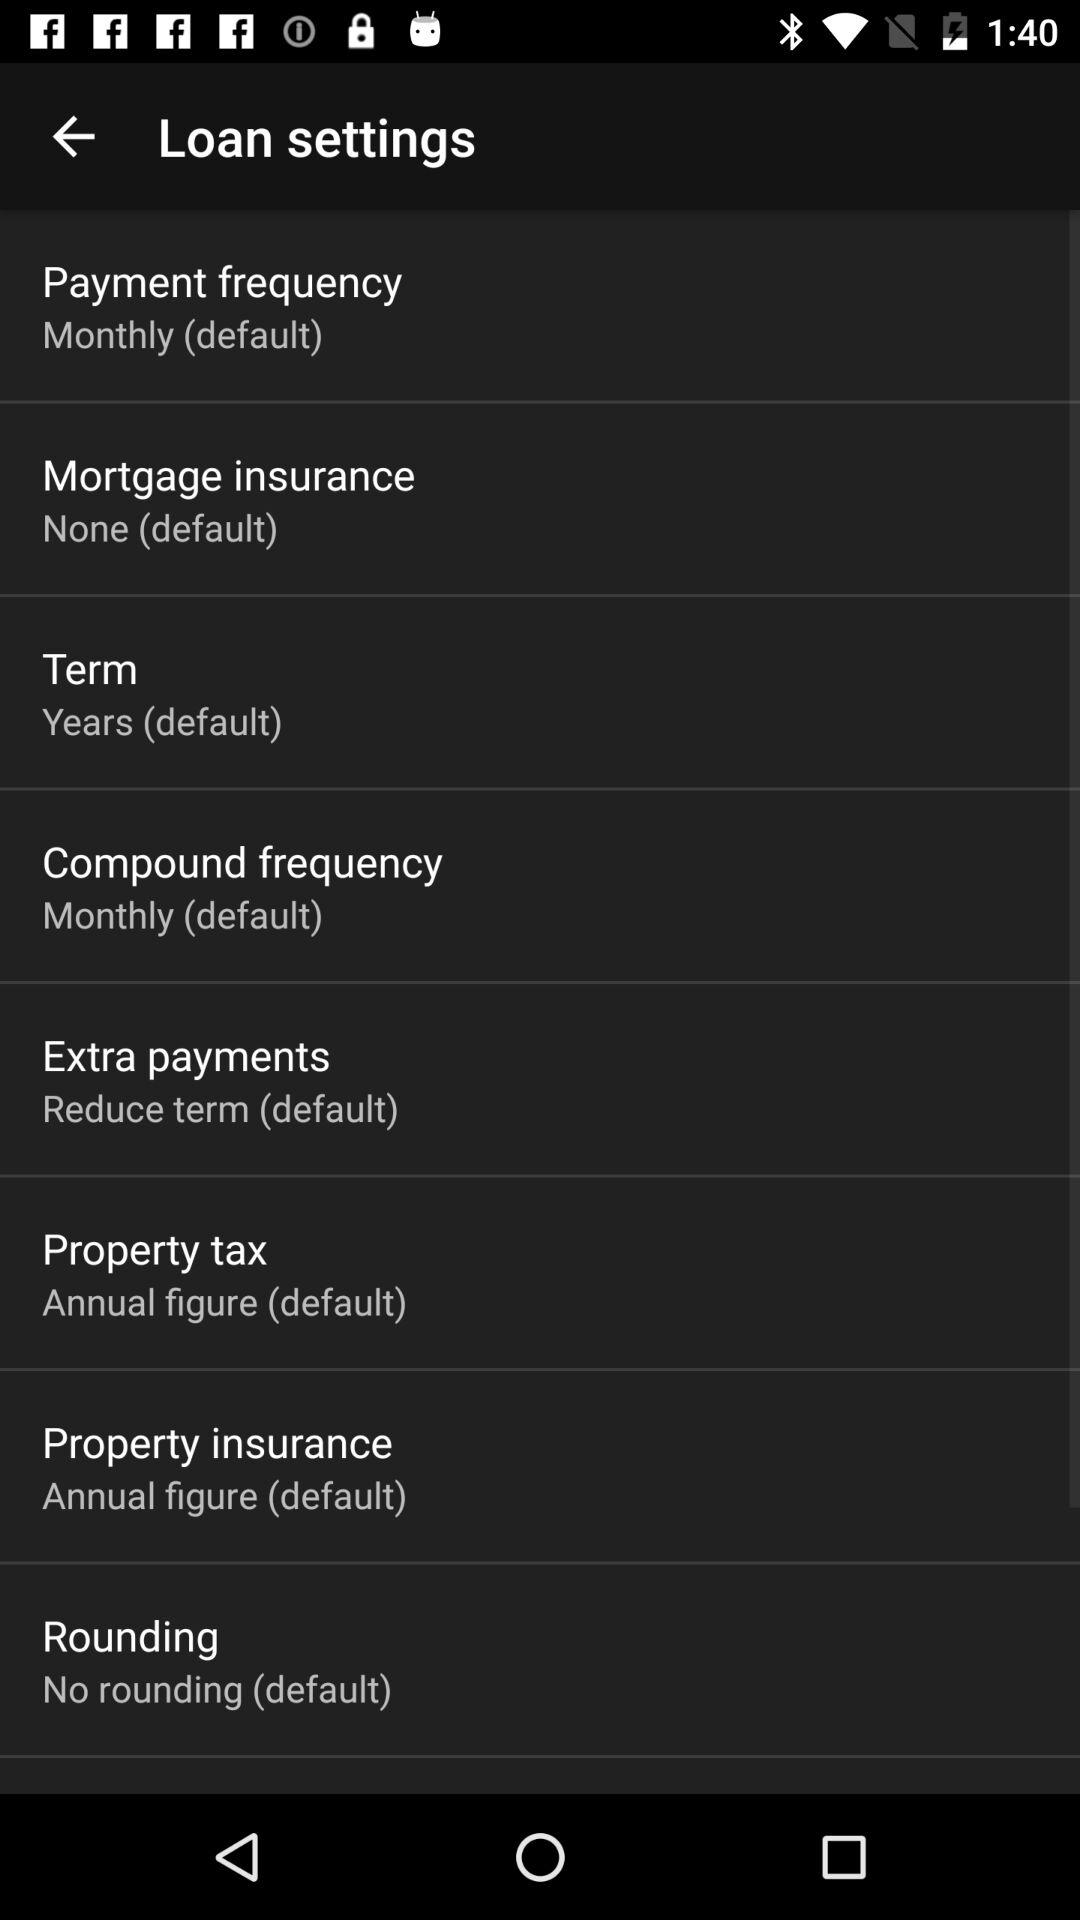What is the setting for term? The setting for term is "Years (default)". 